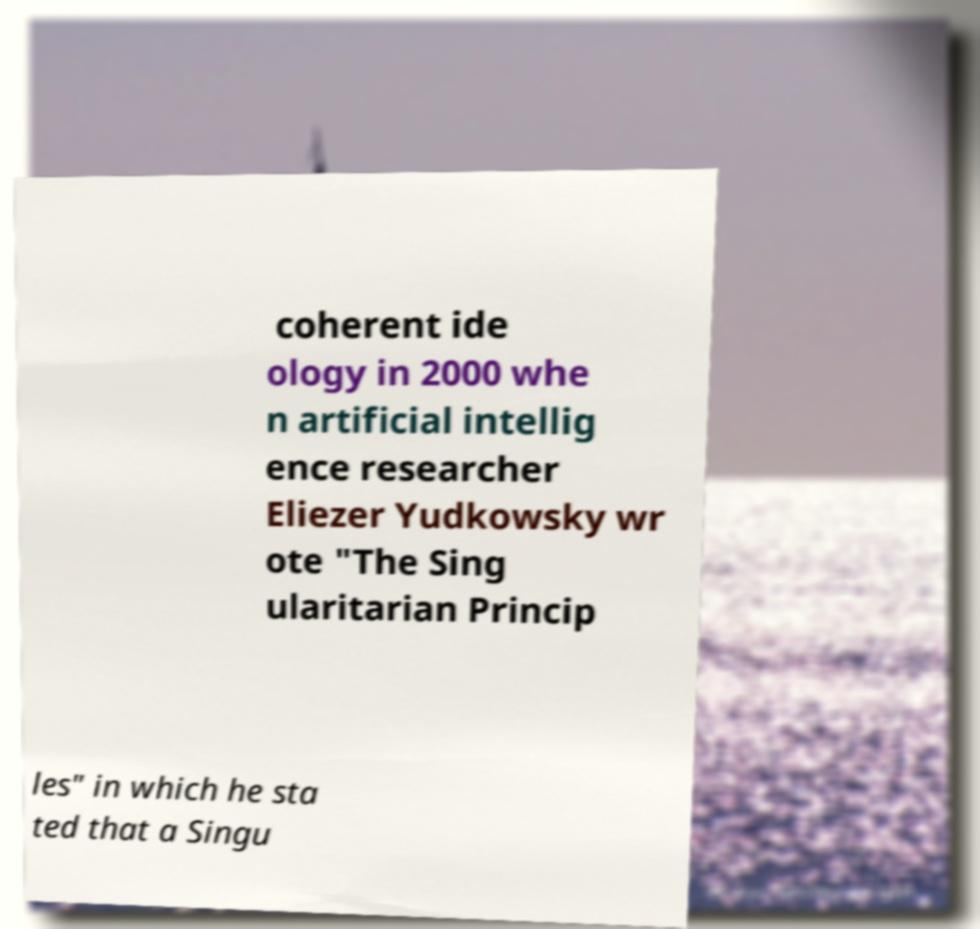Please identify and transcribe the text found in this image. coherent ide ology in 2000 whe n artificial intellig ence researcher Eliezer Yudkowsky wr ote "The Sing ularitarian Princip les" in which he sta ted that a Singu 